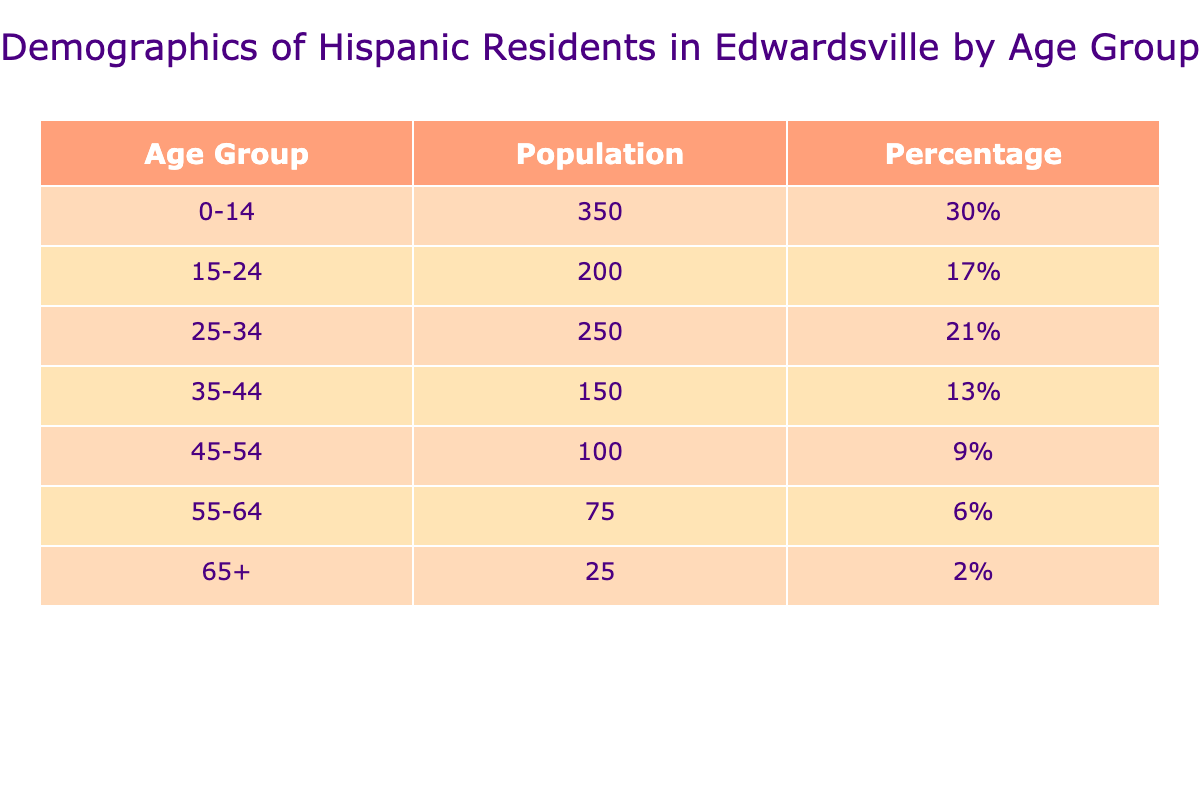What is the total population of Hispanic residents in Edwardsville? To find the total population, we sum the population values from all age groups: 350 (0-14) + 200 (15-24) + 250 (25-34) + 150 (35-44) + 100 (45-54) + 75 (55-64) + 25 (65+) = 1150.
Answer: 1150 What percentage of the Hispanic population is aged 35-44? The percentage of the Hispanic population aged 35-44 can be found directly in the table. The value listed is 13%.
Answer: 13% Is the population of residents aged 55-64 greater than those aged 45-54? To answer this, we compare the population of each age group: 75 (55-64) vs. 100 (45-54). Since 75 is less than 100, the answer is no.
Answer: No What age group has the highest population? Checking the population values, the age group with the highest population is 0-14 years, which has 350 residents.
Answer: 0-14 What is the average population of the age groups listed? To find the average, we first calculate the total population of 1150 and then divide that by the number of age groups, which is 7 (0-14, 15-24, 25-34, 35-44, 45-54, 55-64, 65+). Therefore, 1150/7 = approximately 164.29.
Answer: 164.29 What is the population of residents aged 25-34 compared to those aged 15-24? The number of residents aged 25-34 is 250 and for 15-24 it is 200. So, 250 is greater than 200.
Answer: Yes How many residents are aged 65 and older? The population of residents aged 65 and older is directly found in the table, which lists this age group as having 25 residents.
Answer: 25 What percentage of the total population does the age group 45-54 represent? To calculate this, we take the population of 45-54 (100) and divide it by the total population (1150) and then multiply by 100 to get the percentage: (100/1150) * 100 = approximately 8.7%.
Answer: 8.7% Which age group has the lowest population, and what is that population? Looking through the table, the age group with the lowest population is 65+ with a population of 25.
Answer: 65+ with 25 